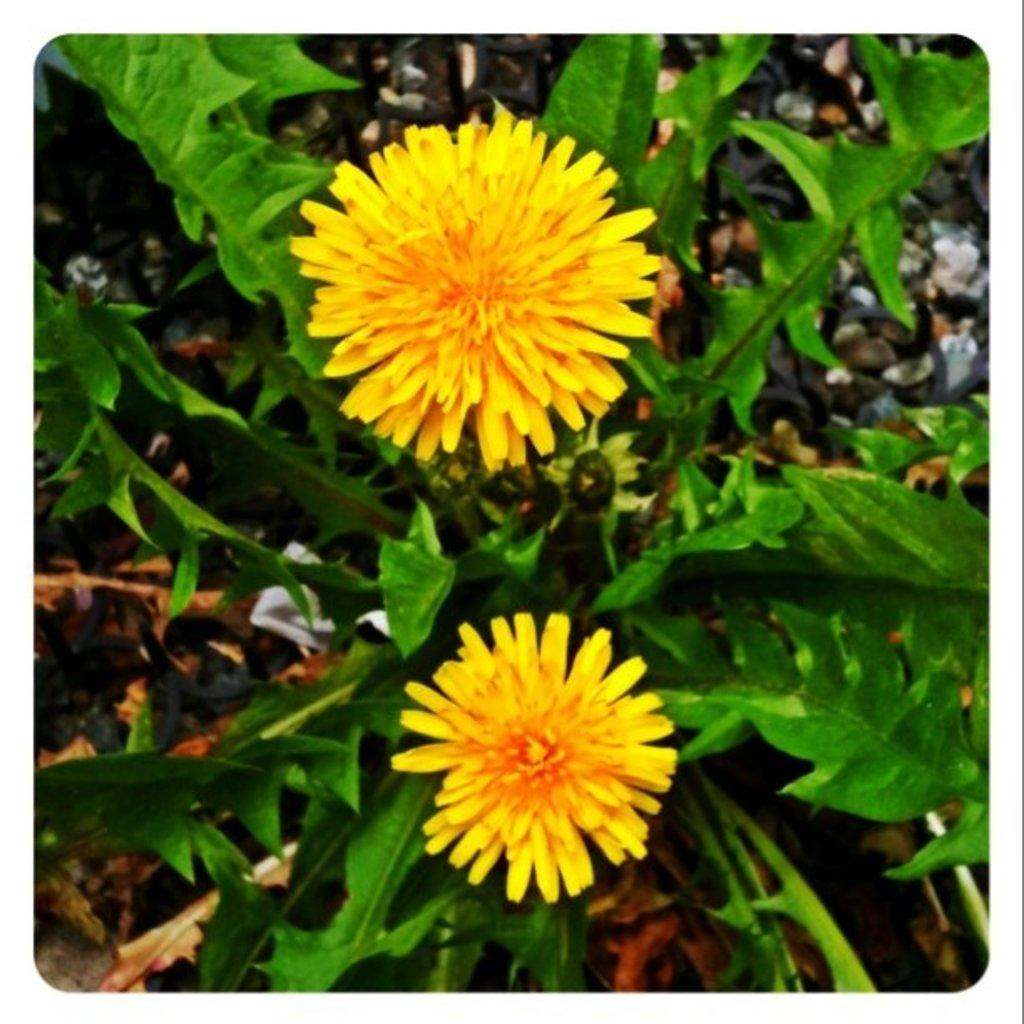What type of plant life is present in the image? There are flowers, buds, and leaves in the image. Can you describe the different stages of growth depicted in the image? The image shows flowers, which are fully bloomed, and buds, which are in the process of blooming. What part of the plant is visible in the image? Leaves are also visible in the image. What songs are being sung by the flowers in the image? There are no songs being sung by the flowers in the image, as flowers do not have the ability to sing. 